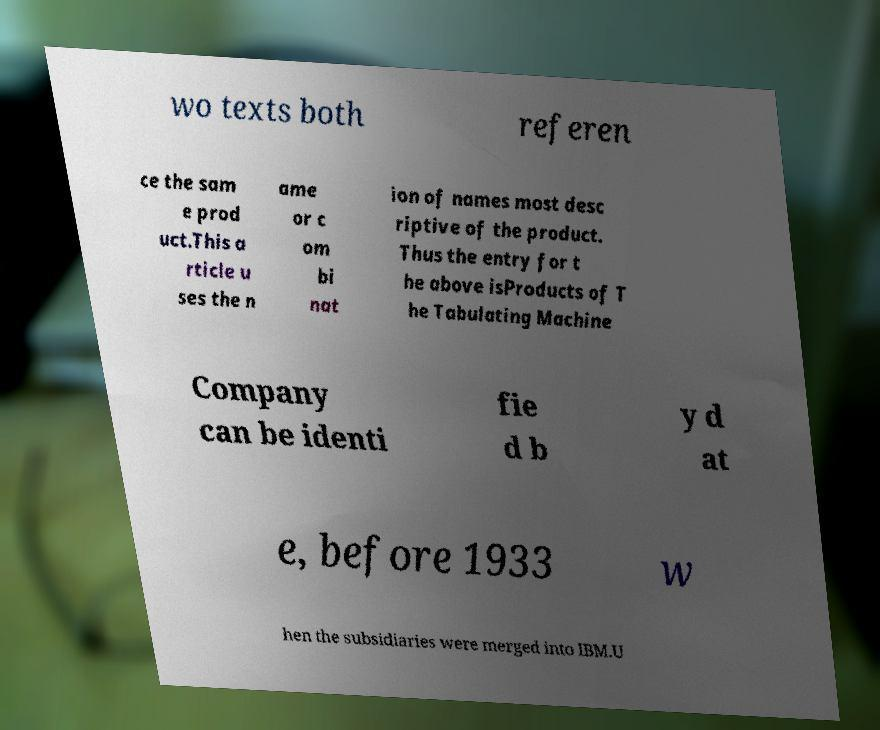For documentation purposes, I need the text within this image transcribed. Could you provide that? wo texts both referen ce the sam e prod uct.This a rticle u ses the n ame or c om bi nat ion of names most desc riptive of the product. Thus the entry for t he above isProducts of T he Tabulating Machine Company can be identi fie d b y d at e, before 1933 w hen the subsidiaries were merged into IBM.U 